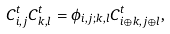Convert formula to latex. <formula><loc_0><loc_0><loc_500><loc_500>C ^ { t } _ { i , j } C ^ { t } _ { k , l } = \phi _ { i , j ; k , l } C ^ { t } _ { i \oplus k , j \oplus l } ,</formula> 